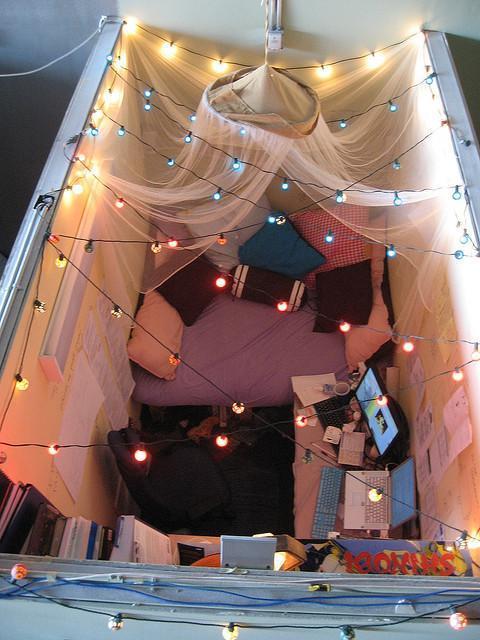How many laptops can you see?
Give a very brief answer. 2. How many sheep are sticking their head through the fence?
Give a very brief answer. 0. 